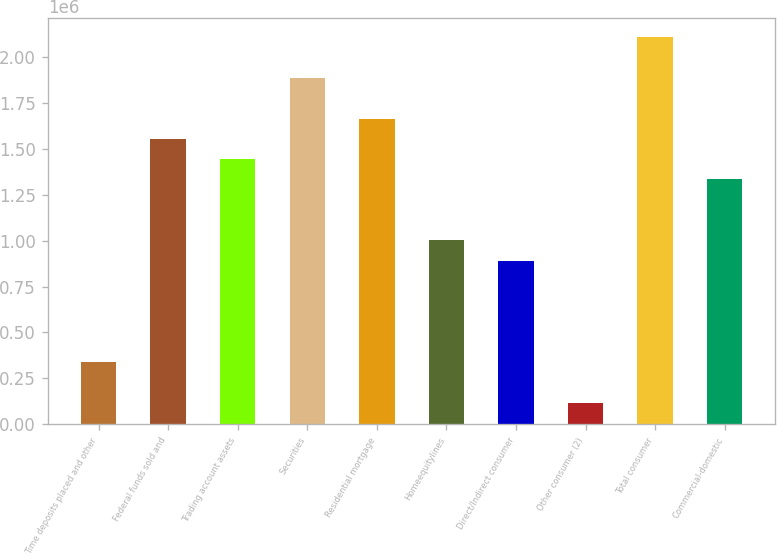<chart> <loc_0><loc_0><loc_500><loc_500><bar_chart><fcel>Time deposits placed and other<fcel>Federal funds sold and<fcel>Trading account assets<fcel>Securities<fcel>Residential mortgage<fcel>Homeequitylines<fcel>Direct/Indirect consumer<fcel>Other consumer (2)<fcel>Total consumer<fcel>Commercial-domestic<nl><fcel>338404<fcel>1.55405e+06<fcel>1.44353e+06<fcel>1.88558e+06<fcel>1.66456e+06<fcel>1.00148e+06<fcel>890968<fcel>117378<fcel>2.10661e+06<fcel>1.33302e+06<nl></chart> 